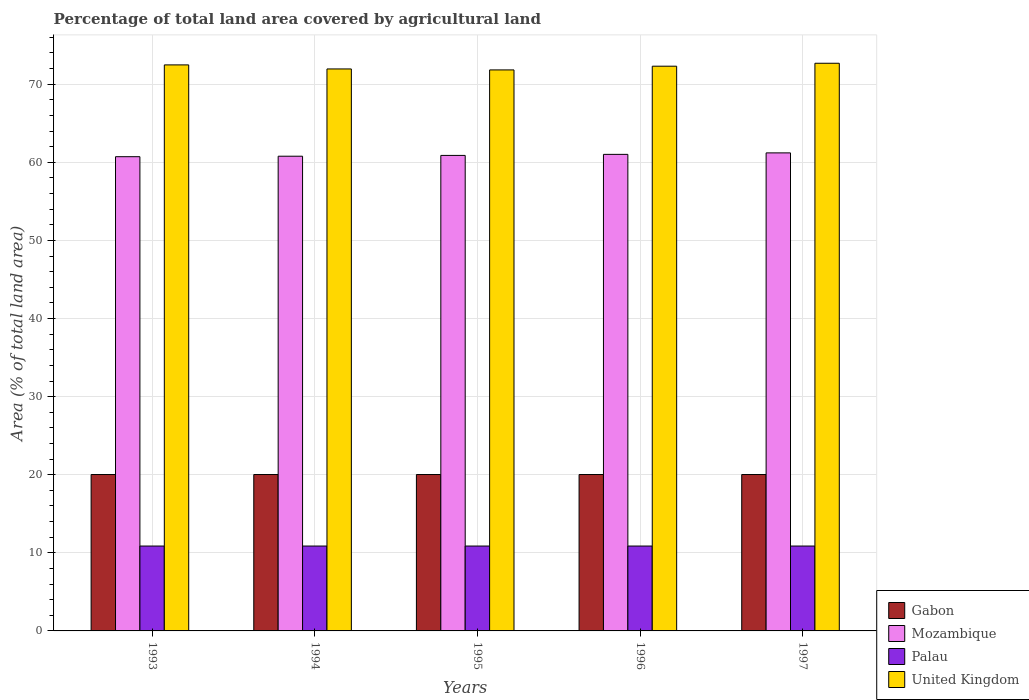Are the number of bars on each tick of the X-axis equal?
Provide a short and direct response. Yes. How many bars are there on the 2nd tick from the left?
Your answer should be very brief. 4. How many bars are there on the 3rd tick from the right?
Your answer should be very brief. 4. In how many cases, is the number of bars for a given year not equal to the number of legend labels?
Your response must be concise. 0. What is the percentage of agricultural land in United Kingdom in 1997?
Ensure brevity in your answer.  72.69. Across all years, what is the maximum percentage of agricultural land in Mozambique?
Keep it short and to the point. 61.21. Across all years, what is the minimum percentage of agricultural land in Palau?
Provide a succinct answer. 10.87. What is the total percentage of agricultural land in Mozambique in the graph?
Keep it short and to the point. 304.62. What is the difference between the percentage of agricultural land in United Kingdom in 1993 and that in 1996?
Provide a short and direct response. 0.17. What is the difference between the percentage of agricultural land in Gabon in 1996 and the percentage of agricultural land in United Kingdom in 1994?
Keep it short and to the point. -51.93. What is the average percentage of agricultural land in Mozambique per year?
Make the answer very short. 60.92. In the year 1996, what is the difference between the percentage of agricultural land in Gabon and percentage of agricultural land in United Kingdom?
Your response must be concise. -52.28. In how many years, is the percentage of agricultural land in United Kingdom greater than 64 %?
Your answer should be very brief. 5. What is the ratio of the percentage of agricultural land in Mozambique in 1993 to that in 1996?
Offer a terse response. 1. Is the difference between the percentage of agricultural land in Gabon in 1994 and 1997 greater than the difference between the percentage of agricultural land in United Kingdom in 1994 and 1997?
Give a very brief answer. Yes. What is the difference between the highest and the second highest percentage of agricultural land in Mozambique?
Offer a very short reply. 0.19. What is the difference between the highest and the lowest percentage of agricultural land in United Kingdom?
Offer a terse response. 0.85. In how many years, is the percentage of agricultural land in Mozambique greater than the average percentage of agricultural land in Mozambique taken over all years?
Your answer should be compact. 2. Is the sum of the percentage of agricultural land in United Kingdom in 1994 and 1995 greater than the maximum percentage of agricultural land in Mozambique across all years?
Provide a short and direct response. Yes. What does the 2nd bar from the left in 1993 represents?
Ensure brevity in your answer.  Mozambique. How many bars are there?
Give a very brief answer. 20. Are all the bars in the graph horizontal?
Your response must be concise. No. How many years are there in the graph?
Keep it short and to the point. 5. What is the difference between two consecutive major ticks on the Y-axis?
Your answer should be compact. 10. Are the values on the major ticks of Y-axis written in scientific E-notation?
Provide a succinct answer. No. Does the graph contain any zero values?
Make the answer very short. No. Does the graph contain grids?
Your response must be concise. Yes. Where does the legend appear in the graph?
Provide a short and direct response. Bottom right. How many legend labels are there?
Offer a very short reply. 4. What is the title of the graph?
Make the answer very short. Percentage of total land area covered by agricultural land. Does "Lower middle income" appear as one of the legend labels in the graph?
Give a very brief answer. No. What is the label or title of the X-axis?
Your answer should be very brief. Years. What is the label or title of the Y-axis?
Ensure brevity in your answer.  Area (% of total land area). What is the Area (% of total land area) of Gabon in 1993?
Give a very brief answer. 20.03. What is the Area (% of total land area) in Mozambique in 1993?
Provide a succinct answer. 60.72. What is the Area (% of total land area) of Palau in 1993?
Offer a terse response. 10.87. What is the Area (% of total land area) in United Kingdom in 1993?
Your answer should be very brief. 72.48. What is the Area (% of total land area) of Gabon in 1994?
Give a very brief answer. 20.03. What is the Area (% of total land area) of Mozambique in 1994?
Your response must be concise. 60.78. What is the Area (% of total land area) of Palau in 1994?
Provide a succinct answer. 10.87. What is the Area (% of total land area) in United Kingdom in 1994?
Provide a succinct answer. 71.96. What is the Area (% of total land area) in Gabon in 1995?
Offer a terse response. 20.03. What is the Area (% of total land area) of Mozambique in 1995?
Your answer should be very brief. 60.89. What is the Area (% of total land area) of Palau in 1995?
Your answer should be very brief. 10.87. What is the Area (% of total land area) in United Kingdom in 1995?
Your response must be concise. 71.83. What is the Area (% of total land area) of Gabon in 1996?
Your answer should be very brief. 20.03. What is the Area (% of total land area) of Mozambique in 1996?
Ensure brevity in your answer.  61.02. What is the Area (% of total land area) of Palau in 1996?
Offer a terse response. 10.87. What is the Area (% of total land area) of United Kingdom in 1996?
Make the answer very short. 72.31. What is the Area (% of total land area) in Gabon in 1997?
Provide a short and direct response. 20.03. What is the Area (% of total land area) in Mozambique in 1997?
Give a very brief answer. 61.21. What is the Area (% of total land area) of Palau in 1997?
Keep it short and to the point. 10.87. What is the Area (% of total land area) of United Kingdom in 1997?
Provide a succinct answer. 72.69. Across all years, what is the maximum Area (% of total land area) in Gabon?
Your answer should be very brief. 20.03. Across all years, what is the maximum Area (% of total land area) of Mozambique?
Your answer should be very brief. 61.21. Across all years, what is the maximum Area (% of total land area) of Palau?
Your answer should be very brief. 10.87. Across all years, what is the maximum Area (% of total land area) in United Kingdom?
Provide a short and direct response. 72.69. Across all years, what is the minimum Area (% of total land area) of Gabon?
Give a very brief answer. 20.03. Across all years, what is the minimum Area (% of total land area) of Mozambique?
Your response must be concise. 60.72. Across all years, what is the minimum Area (% of total land area) in Palau?
Provide a succinct answer. 10.87. Across all years, what is the minimum Area (% of total land area) in United Kingdom?
Your response must be concise. 71.83. What is the total Area (% of total land area) in Gabon in the graph?
Your answer should be compact. 100.13. What is the total Area (% of total land area) of Mozambique in the graph?
Make the answer very short. 304.62. What is the total Area (% of total land area) of Palau in the graph?
Make the answer very short. 54.35. What is the total Area (% of total land area) in United Kingdom in the graph?
Offer a very short reply. 361.27. What is the difference between the Area (% of total land area) in Gabon in 1993 and that in 1994?
Keep it short and to the point. 0. What is the difference between the Area (% of total land area) of Mozambique in 1993 and that in 1994?
Offer a very short reply. -0.06. What is the difference between the Area (% of total land area) in Palau in 1993 and that in 1994?
Ensure brevity in your answer.  0. What is the difference between the Area (% of total land area) in United Kingdom in 1993 and that in 1994?
Your response must be concise. 0.52. What is the difference between the Area (% of total land area) in Mozambique in 1993 and that in 1995?
Provide a short and direct response. -0.17. What is the difference between the Area (% of total land area) of United Kingdom in 1993 and that in 1995?
Your answer should be compact. 0.64. What is the difference between the Area (% of total land area) in Gabon in 1993 and that in 1996?
Provide a short and direct response. 0. What is the difference between the Area (% of total land area) in Mozambique in 1993 and that in 1996?
Provide a short and direct response. -0.3. What is the difference between the Area (% of total land area) in United Kingdom in 1993 and that in 1996?
Offer a terse response. 0.17. What is the difference between the Area (% of total land area) in Mozambique in 1993 and that in 1997?
Keep it short and to the point. -0.49. What is the difference between the Area (% of total land area) of Palau in 1993 and that in 1997?
Your answer should be compact. 0. What is the difference between the Area (% of total land area) of United Kingdom in 1993 and that in 1997?
Offer a terse response. -0.21. What is the difference between the Area (% of total land area) of Mozambique in 1994 and that in 1995?
Provide a short and direct response. -0.1. What is the difference between the Area (% of total land area) in Palau in 1994 and that in 1995?
Your response must be concise. 0. What is the difference between the Area (% of total land area) of United Kingdom in 1994 and that in 1995?
Offer a terse response. 0.12. What is the difference between the Area (% of total land area) in Mozambique in 1994 and that in 1996?
Make the answer very short. -0.24. What is the difference between the Area (% of total land area) of Palau in 1994 and that in 1996?
Provide a succinct answer. 0. What is the difference between the Area (% of total land area) of United Kingdom in 1994 and that in 1996?
Ensure brevity in your answer.  -0.35. What is the difference between the Area (% of total land area) of Mozambique in 1994 and that in 1997?
Keep it short and to the point. -0.43. What is the difference between the Area (% of total land area) in Palau in 1994 and that in 1997?
Your answer should be very brief. 0. What is the difference between the Area (% of total land area) of United Kingdom in 1994 and that in 1997?
Give a very brief answer. -0.73. What is the difference between the Area (% of total land area) of Mozambique in 1995 and that in 1996?
Keep it short and to the point. -0.13. What is the difference between the Area (% of total land area) of United Kingdom in 1995 and that in 1996?
Give a very brief answer. -0.48. What is the difference between the Area (% of total land area) in Mozambique in 1995 and that in 1997?
Your answer should be very brief. -0.32. What is the difference between the Area (% of total land area) of United Kingdom in 1995 and that in 1997?
Provide a succinct answer. -0.85. What is the difference between the Area (% of total land area) of Gabon in 1996 and that in 1997?
Your response must be concise. 0. What is the difference between the Area (% of total land area) in Mozambique in 1996 and that in 1997?
Offer a very short reply. -0.19. What is the difference between the Area (% of total land area) of Palau in 1996 and that in 1997?
Make the answer very short. 0. What is the difference between the Area (% of total land area) in United Kingdom in 1996 and that in 1997?
Your answer should be compact. -0.38. What is the difference between the Area (% of total land area) of Gabon in 1993 and the Area (% of total land area) of Mozambique in 1994?
Offer a very short reply. -40.76. What is the difference between the Area (% of total land area) of Gabon in 1993 and the Area (% of total land area) of Palau in 1994?
Make the answer very short. 9.16. What is the difference between the Area (% of total land area) in Gabon in 1993 and the Area (% of total land area) in United Kingdom in 1994?
Make the answer very short. -51.93. What is the difference between the Area (% of total land area) of Mozambique in 1993 and the Area (% of total land area) of Palau in 1994?
Provide a short and direct response. 49.85. What is the difference between the Area (% of total land area) of Mozambique in 1993 and the Area (% of total land area) of United Kingdom in 1994?
Offer a very short reply. -11.24. What is the difference between the Area (% of total land area) in Palau in 1993 and the Area (% of total land area) in United Kingdom in 1994?
Offer a very short reply. -61.09. What is the difference between the Area (% of total land area) in Gabon in 1993 and the Area (% of total land area) in Mozambique in 1995?
Keep it short and to the point. -40.86. What is the difference between the Area (% of total land area) of Gabon in 1993 and the Area (% of total land area) of Palau in 1995?
Give a very brief answer. 9.16. What is the difference between the Area (% of total land area) of Gabon in 1993 and the Area (% of total land area) of United Kingdom in 1995?
Offer a very short reply. -51.81. What is the difference between the Area (% of total land area) of Mozambique in 1993 and the Area (% of total land area) of Palau in 1995?
Offer a terse response. 49.85. What is the difference between the Area (% of total land area) of Mozambique in 1993 and the Area (% of total land area) of United Kingdom in 1995?
Your answer should be very brief. -11.11. What is the difference between the Area (% of total land area) in Palau in 1993 and the Area (% of total land area) in United Kingdom in 1995?
Offer a very short reply. -60.97. What is the difference between the Area (% of total land area) in Gabon in 1993 and the Area (% of total land area) in Mozambique in 1996?
Make the answer very short. -40.99. What is the difference between the Area (% of total land area) of Gabon in 1993 and the Area (% of total land area) of Palau in 1996?
Offer a very short reply. 9.16. What is the difference between the Area (% of total land area) in Gabon in 1993 and the Area (% of total land area) in United Kingdom in 1996?
Your answer should be compact. -52.28. What is the difference between the Area (% of total land area) in Mozambique in 1993 and the Area (% of total land area) in Palau in 1996?
Provide a short and direct response. 49.85. What is the difference between the Area (% of total land area) of Mozambique in 1993 and the Area (% of total land area) of United Kingdom in 1996?
Offer a terse response. -11.59. What is the difference between the Area (% of total land area) in Palau in 1993 and the Area (% of total land area) in United Kingdom in 1996?
Give a very brief answer. -61.44. What is the difference between the Area (% of total land area) in Gabon in 1993 and the Area (% of total land area) in Mozambique in 1997?
Provide a short and direct response. -41.19. What is the difference between the Area (% of total land area) of Gabon in 1993 and the Area (% of total land area) of Palau in 1997?
Make the answer very short. 9.16. What is the difference between the Area (% of total land area) of Gabon in 1993 and the Area (% of total land area) of United Kingdom in 1997?
Your answer should be compact. -52.66. What is the difference between the Area (% of total land area) of Mozambique in 1993 and the Area (% of total land area) of Palau in 1997?
Offer a terse response. 49.85. What is the difference between the Area (% of total land area) in Mozambique in 1993 and the Area (% of total land area) in United Kingdom in 1997?
Your response must be concise. -11.96. What is the difference between the Area (% of total land area) in Palau in 1993 and the Area (% of total land area) in United Kingdom in 1997?
Keep it short and to the point. -61.82. What is the difference between the Area (% of total land area) of Gabon in 1994 and the Area (% of total land area) of Mozambique in 1995?
Provide a succinct answer. -40.86. What is the difference between the Area (% of total land area) of Gabon in 1994 and the Area (% of total land area) of Palau in 1995?
Offer a terse response. 9.16. What is the difference between the Area (% of total land area) in Gabon in 1994 and the Area (% of total land area) in United Kingdom in 1995?
Your answer should be very brief. -51.81. What is the difference between the Area (% of total land area) in Mozambique in 1994 and the Area (% of total land area) in Palau in 1995?
Your response must be concise. 49.92. What is the difference between the Area (% of total land area) in Mozambique in 1994 and the Area (% of total land area) in United Kingdom in 1995?
Your answer should be very brief. -11.05. What is the difference between the Area (% of total land area) in Palau in 1994 and the Area (% of total land area) in United Kingdom in 1995?
Give a very brief answer. -60.97. What is the difference between the Area (% of total land area) of Gabon in 1994 and the Area (% of total land area) of Mozambique in 1996?
Give a very brief answer. -40.99. What is the difference between the Area (% of total land area) of Gabon in 1994 and the Area (% of total land area) of Palau in 1996?
Ensure brevity in your answer.  9.16. What is the difference between the Area (% of total land area) of Gabon in 1994 and the Area (% of total land area) of United Kingdom in 1996?
Your answer should be very brief. -52.28. What is the difference between the Area (% of total land area) in Mozambique in 1994 and the Area (% of total land area) in Palau in 1996?
Your response must be concise. 49.92. What is the difference between the Area (% of total land area) of Mozambique in 1994 and the Area (% of total land area) of United Kingdom in 1996?
Provide a short and direct response. -11.53. What is the difference between the Area (% of total land area) of Palau in 1994 and the Area (% of total land area) of United Kingdom in 1996?
Offer a very short reply. -61.44. What is the difference between the Area (% of total land area) of Gabon in 1994 and the Area (% of total land area) of Mozambique in 1997?
Ensure brevity in your answer.  -41.19. What is the difference between the Area (% of total land area) in Gabon in 1994 and the Area (% of total land area) in Palau in 1997?
Provide a short and direct response. 9.16. What is the difference between the Area (% of total land area) in Gabon in 1994 and the Area (% of total land area) in United Kingdom in 1997?
Give a very brief answer. -52.66. What is the difference between the Area (% of total land area) in Mozambique in 1994 and the Area (% of total land area) in Palau in 1997?
Make the answer very short. 49.92. What is the difference between the Area (% of total land area) in Mozambique in 1994 and the Area (% of total land area) in United Kingdom in 1997?
Provide a succinct answer. -11.9. What is the difference between the Area (% of total land area) of Palau in 1994 and the Area (% of total land area) of United Kingdom in 1997?
Keep it short and to the point. -61.82. What is the difference between the Area (% of total land area) in Gabon in 1995 and the Area (% of total land area) in Mozambique in 1996?
Give a very brief answer. -40.99. What is the difference between the Area (% of total land area) in Gabon in 1995 and the Area (% of total land area) in Palau in 1996?
Ensure brevity in your answer.  9.16. What is the difference between the Area (% of total land area) of Gabon in 1995 and the Area (% of total land area) of United Kingdom in 1996?
Keep it short and to the point. -52.28. What is the difference between the Area (% of total land area) of Mozambique in 1995 and the Area (% of total land area) of Palau in 1996?
Your answer should be compact. 50.02. What is the difference between the Area (% of total land area) of Mozambique in 1995 and the Area (% of total land area) of United Kingdom in 1996?
Your answer should be compact. -11.42. What is the difference between the Area (% of total land area) in Palau in 1995 and the Area (% of total land area) in United Kingdom in 1996?
Offer a very short reply. -61.44. What is the difference between the Area (% of total land area) of Gabon in 1995 and the Area (% of total land area) of Mozambique in 1997?
Your response must be concise. -41.19. What is the difference between the Area (% of total land area) in Gabon in 1995 and the Area (% of total land area) in Palau in 1997?
Offer a very short reply. 9.16. What is the difference between the Area (% of total land area) in Gabon in 1995 and the Area (% of total land area) in United Kingdom in 1997?
Your response must be concise. -52.66. What is the difference between the Area (% of total land area) in Mozambique in 1995 and the Area (% of total land area) in Palau in 1997?
Your response must be concise. 50.02. What is the difference between the Area (% of total land area) in Mozambique in 1995 and the Area (% of total land area) in United Kingdom in 1997?
Your response must be concise. -11.8. What is the difference between the Area (% of total land area) of Palau in 1995 and the Area (% of total land area) of United Kingdom in 1997?
Provide a succinct answer. -61.82. What is the difference between the Area (% of total land area) in Gabon in 1996 and the Area (% of total land area) in Mozambique in 1997?
Provide a short and direct response. -41.19. What is the difference between the Area (% of total land area) of Gabon in 1996 and the Area (% of total land area) of Palau in 1997?
Make the answer very short. 9.16. What is the difference between the Area (% of total land area) of Gabon in 1996 and the Area (% of total land area) of United Kingdom in 1997?
Make the answer very short. -52.66. What is the difference between the Area (% of total land area) in Mozambique in 1996 and the Area (% of total land area) in Palau in 1997?
Offer a very short reply. 50.15. What is the difference between the Area (% of total land area) in Mozambique in 1996 and the Area (% of total land area) in United Kingdom in 1997?
Provide a short and direct response. -11.67. What is the difference between the Area (% of total land area) in Palau in 1996 and the Area (% of total land area) in United Kingdom in 1997?
Give a very brief answer. -61.82. What is the average Area (% of total land area) in Gabon per year?
Keep it short and to the point. 20.03. What is the average Area (% of total land area) in Mozambique per year?
Offer a very short reply. 60.92. What is the average Area (% of total land area) of Palau per year?
Ensure brevity in your answer.  10.87. What is the average Area (% of total land area) of United Kingdom per year?
Keep it short and to the point. 72.25. In the year 1993, what is the difference between the Area (% of total land area) in Gabon and Area (% of total land area) in Mozambique?
Your response must be concise. -40.7. In the year 1993, what is the difference between the Area (% of total land area) in Gabon and Area (% of total land area) in Palau?
Offer a terse response. 9.16. In the year 1993, what is the difference between the Area (% of total land area) in Gabon and Area (% of total land area) in United Kingdom?
Your answer should be very brief. -52.45. In the year 1993, what is the difference between the Area (% of total land area) in Mozambique and Area (% of total land area) in Palau?
Keep it short and to the point. 49.85. In the year 1993, what is the difference between the Area (% of total land area) of Mozambique and Area (% of total land area) of United Kingdom?
Ensure brevity in your answer.  -11.75. In the year 1993, what is the difference between the Area (% of total land area) in Palau and Area (% of total land area) in United Kingdom?
Your answer should be compact. -61.61. In the year 1994, what is the difference between the Area (% of total land area) of Gabon and Area (% of total land area) of Mozambique?
Offer a terse response. -40.76. In the year 1994, what is the difference between the Area (% of total land area) in Gabon and Area (% of total land area) in Palau?
Provide a short and direct response. 9.16. In the year 1994, what is the difference between the Area (% of total land area) of Gabon and Area (% of total land area) of United Kingdom?
Your response must be concise. -51.93. In the year 1994, what is the difference between the Area (% of total land area) in Mozambique and Area (% of total land area) in Palau?
Offer a terse response. 49.92. In the year 1994, what is the difference between the Area (% of total land area) in Mozambique and Area (% of total land area) in United Kingdom?
Keep it short and to the point. -11.17. In the year 1994, what is the difference between the Area (% of total land area) in Palau and Area (% of total land area) in United Kingdom?
Make the answer very short. -61.09. In the year 1995, what is the difference between the Area (% of total land area) in Gabon and Area (% of total land area) in Mozambique?
Your answer should be very brief. -40.86. In the year 1995, what is the difference between the Area (% of total land area) in Gabon and Area (% of total land area) in Palau?
Provide a short and direct response. 9.16. In the year 1995, what is the difference between the Area (% of total land area) of Gabon and Area (% of total land area) of United Kingdom?
Make the answer very short. -51.81. In the year 1995, what is the difference between the Area (% of total land area) in Mozambique and Area (% of total land area) in Palau?
Your answer should be compact. 50.02. In the year 1995, what is the difference between the Area (% of total land area) of Mozambique and Area (% of total land area) of United Kingdom?
Your response must be concise. -10.95. In the year 1995, what is the difference between the Area (% of total land area) in Palau and Area (% of total land area) in United Kingdom?
Give a very brief answer. -60.97. In the year 1996, what is the difference between the Area (% of total land area) in Gabon and Area (% of total land area) in Mozambique?
Ensure brevity in your answer.  -40.99. In the year 1996, what is the difference between the Area (% of total land area) in Gabon and Area (% of total land area) in Palau?
Give a very brief answer. 9.16. In the year 1996, what is the difference between the Area (% of total land area) in Gabon and Area (% of total land area) in United Kingdom?
Offer a very short reply. -52.28. In the year 1996, what is the difference between the Area (% of total land area) in Mozambique and Area (% of total land area) in Palau?
Your answer should be compact. 50.15. In the year 1996, what is the difference between the Area (% of total land area) in Mozambique and Area (% of total land area) in United Kingdom?
Provide a short and direct response. -11.29. In the year 1996, what is the difference between the Area (% of total land area) of Palau and Area (% of total land area) of United Kingdom?
Keep it short and to the point. -61.44. In the year 1997, what is the difference between the Area (% of total land area) of Gabon and Area (% of total land area) of Mozambique?
Ensure brevity in your answer.  -41.19. In the year 1997, what is the difference between the Area (% of total land area) of Gabon and Area (% of total land area) of Palau?
Keep it short and to the point. 9.16. In the year 1997, what is the difference between the Area (% of total land area) in Gabon and Area (% of total land area) in United Kingdom?
Provide a short and direct response. -52.66. In the year 1997, what is the difference between the Area (% of total land area) of Mozambique and Area (% of total land area) of Palau?
Provide a short and direct response. 50.34. In the year 1997, what is the difference between the Area (% of total land area) in Mozambique and Area (% of total land area) in United Kingdom?
Your answer should be very brief. -11.48. In the year 1997, what is the difference between the Area (% of total land area) in Palau and Area (% of total land area) in United Kingdom?
Your response must be concise. -61.82. What is the ratio of the Area (% of total land area) of Gabon in 1993 to that in 1994?
Offer a terse response. 1. What is the ratio of the Area (% of total land area) of Mozambique in 1993 to that in 1994?
Your response must be concise. 1. What is the ratio of the Area (% of total land area) of Palau in 1993 to that in 1994?
Ensure brevity in your answer.  1. What is the ratio of the Area (% of total land area) in United Kingdom in 1993 to that in 1994?
Offer a terse response. 1.01. What is the ratio of the Area (% of total land area) in Gabon in 1993 to that in 1995?
Offer a terse response. 1. What is the ratio of the Area (% of total land area) in United Kingdom in 1993 to that in 1995?
Ensure brevity in your answer.  1.01. What is the ratio of the Area (% of total land area) of Gabon in 1993 to that in 1996?
Ensure brevity in your answer.  1. What is the ratio of the Area (% of total land area) in Mozambique in 1993 to that in 1996?
Make the answer very short. 1. What is the ratio of the Area (% of total land area) in United Kingdom in 1993 to that in 1996?
Keep it short and to the point. 1. What is the ratio of the Area (% of total land area) of Mozambique in 1993 to that in 1997?
Make the answer very short. 0.99. What is the ratio of the Area (% of total land area) in Palau in 1993 to that in 1997?
Provide a succinct answer. 1. What is the ratio of the Area (% of total land area) in United Kingdom in 1993 to that in 1997?
Offer a terse response. 1. What is the ratio of the Area (% of total land area) of Mozambique in 1994 to that in 1995?
Ensure brevity in your answer.  1. What is the ratio of the Area (% of total land area) of Palau in 1994 to that in 1995?
Your answer should be compact. 1. What is the ratio of the Area (% of total land area) of Gabon in 1994 to that in 1996?
Your answer should be compact. 1. What is the ratio of the Area (% of total land area) in Mozambique in 1994 to that in 1996?
Keep it short and to the point. 1. What is the ratio of the Area (% of total land area) in Palau in 1994 to that in 1996?
Offer a very short reply. 1. What is the ratio of the Area (% of total land area) of United Kingdom in 1994 to that in 1996?
Your answer should be very brief. 1. What is the ratio of the Area (% of total land area) of Gabon in 1994 to that in 1997?
Offer a terse response. 1. What is the ratio of the Area (% of total land area) of Palau in 1994 to that in 1997?
Offer a terse response. 1. What is the ratio of the Area (% of total land area) in United Kingdom in 1994 to that in 1997?
Your answer should be compact. 0.99. What is the ratio of the Area (% of total land area) in Gabon in 1995 to that in 1996?
Ensure brevity in your answer.  1. What is the ratio of the Area (% of total land area) in Mozambique in 1995 to that in 1996?
Keep it short and to the point. 1. What is the ratio of the Area (% of total land area) of Palau in 1995 to that in 1996?
Your answer should be very brief. 1. What is the ratio of the Area (% of total land area) of United Kingdom in 1995 to that in 1996?
Keep it short and to the point. 0.99. What is the ratio of the Area (% of total land area) in Gabon in 1995 to that in 1997?
Your answer should be compact. 1. What is the ratio of the Area (% of total land area) in Mozambique in 1995 to that in 1997?
Keep it short and to the point. 0.99. What is the ratio of the Area (% of total land area) of United Kingdom in 1995 to that in 1997?
Provide a short and direct response. 0.99. What is the ratio of the Area (% of total land area) of Mozambique in 1996 to that in 1997?
Make the answer very short. 1. What is the ratio of the Area (% of total land area) in Palau in 1996 to that in 1997?
Give a very brief answer. 1. What is the difference between the highest and the second highest Area (% of total land area) in Mozambique?
Give a very brief answer. 0.19. What is the difference between the highest and the second highest Area (% of total land area) in United Kingdom?
Make the answer very short. 0.21. What is the difference between the highest and the lowest Area (% of total land area) in Gabon?
Offer a terse response. 0. What is the difference between the highest and the lowest Area (% of total land area) in Mozambique?
Your answer should be compact. 0.49. What is the difference between the highest and the lowest Area (% of total land area) of United Kingdom?
Your response must be concise. 0.85. 